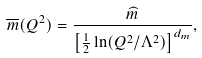Convert formula to latex. <formula><loc_0><loc_0><loc_500><loc_500>\overline { m } ( Q ^ { 2 } ) = \frac { \widehat { m } } { \left [ \frac { 1 } { 2 } \ln ( Q ^ { 2 } / \Lambda ^ { 2 } ) \right ] ^ { d _ { m } } } ,</formula> 